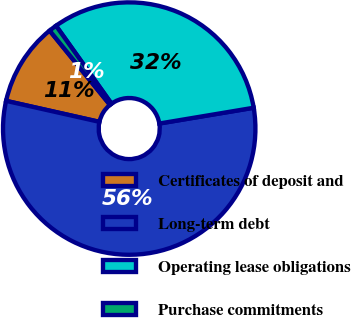Convert chart. <chart><loc_0><loc_0><loc_500><loc_500><pie_chart><fcel>Certificates of deposit and<fcel>Long-term debt<fcel>Operating lease obligations<fcel>Purchase commitments<nl><fcel>10.62%<fcel>56.16%<fcel>32.21%<fcel>1.01%<nl></chart> 